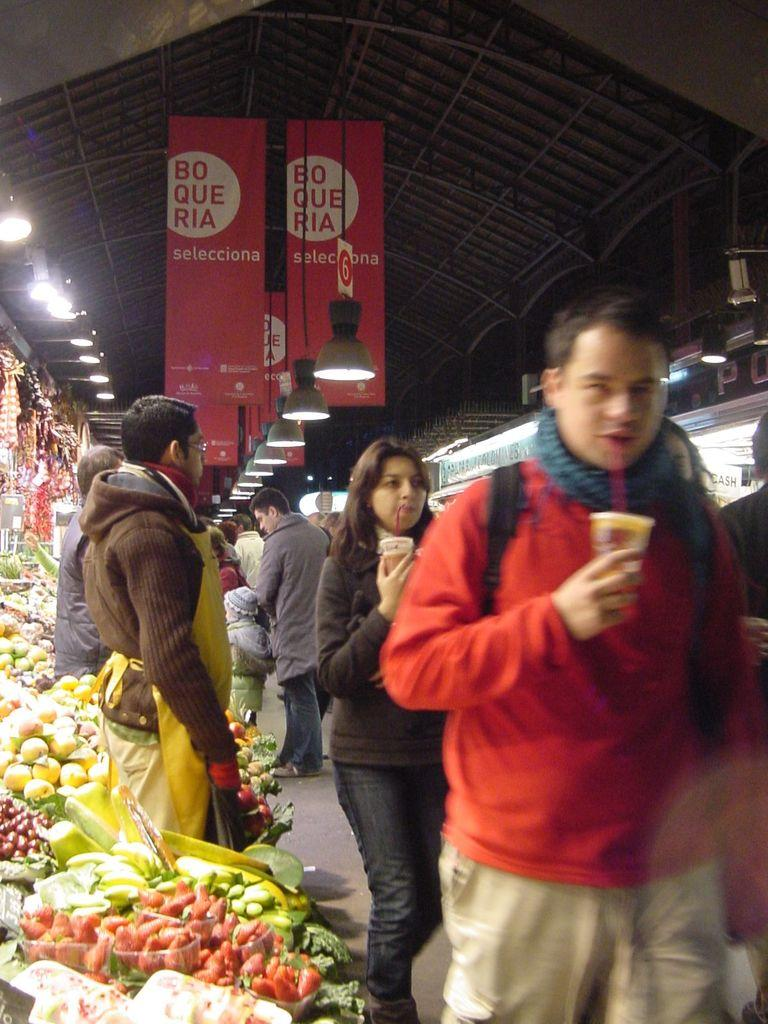What can be seen in the image involving people? There are persons standing in the image. What type of food items are present in the image? There are fruits and vegetables in the image. Where are the fruits and vegetables located in the image? The fruits and vegetables are located in the left corner of the image. What type of legal advice is the lawyer providing in the image? There is no lawyer present in the image, so no legal advice can be provided. What title is displayed on the pail in the image? There is no pail present in the image, so no title can be displayed on it. 